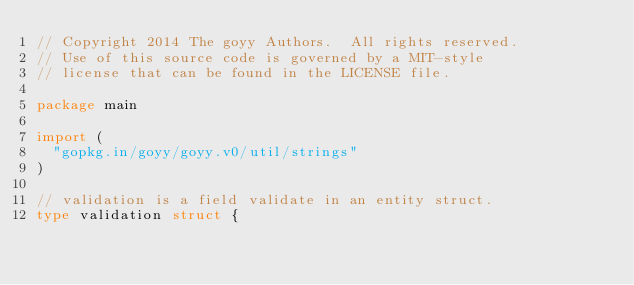<code> <loc_0><loc_0><loc_500><loc_500><_Go_>// Copyright 2014 The goyy Authors.  All rights reserved.
// Use of this source code is governed by a MIT-style
// license that can be found in the LICENSE file.

package main

import (
	"gopkg.in/goyy/goyy.v0/util/strings"
)

// validation is a field validate in an entity struct.
type validation struct {</code> 